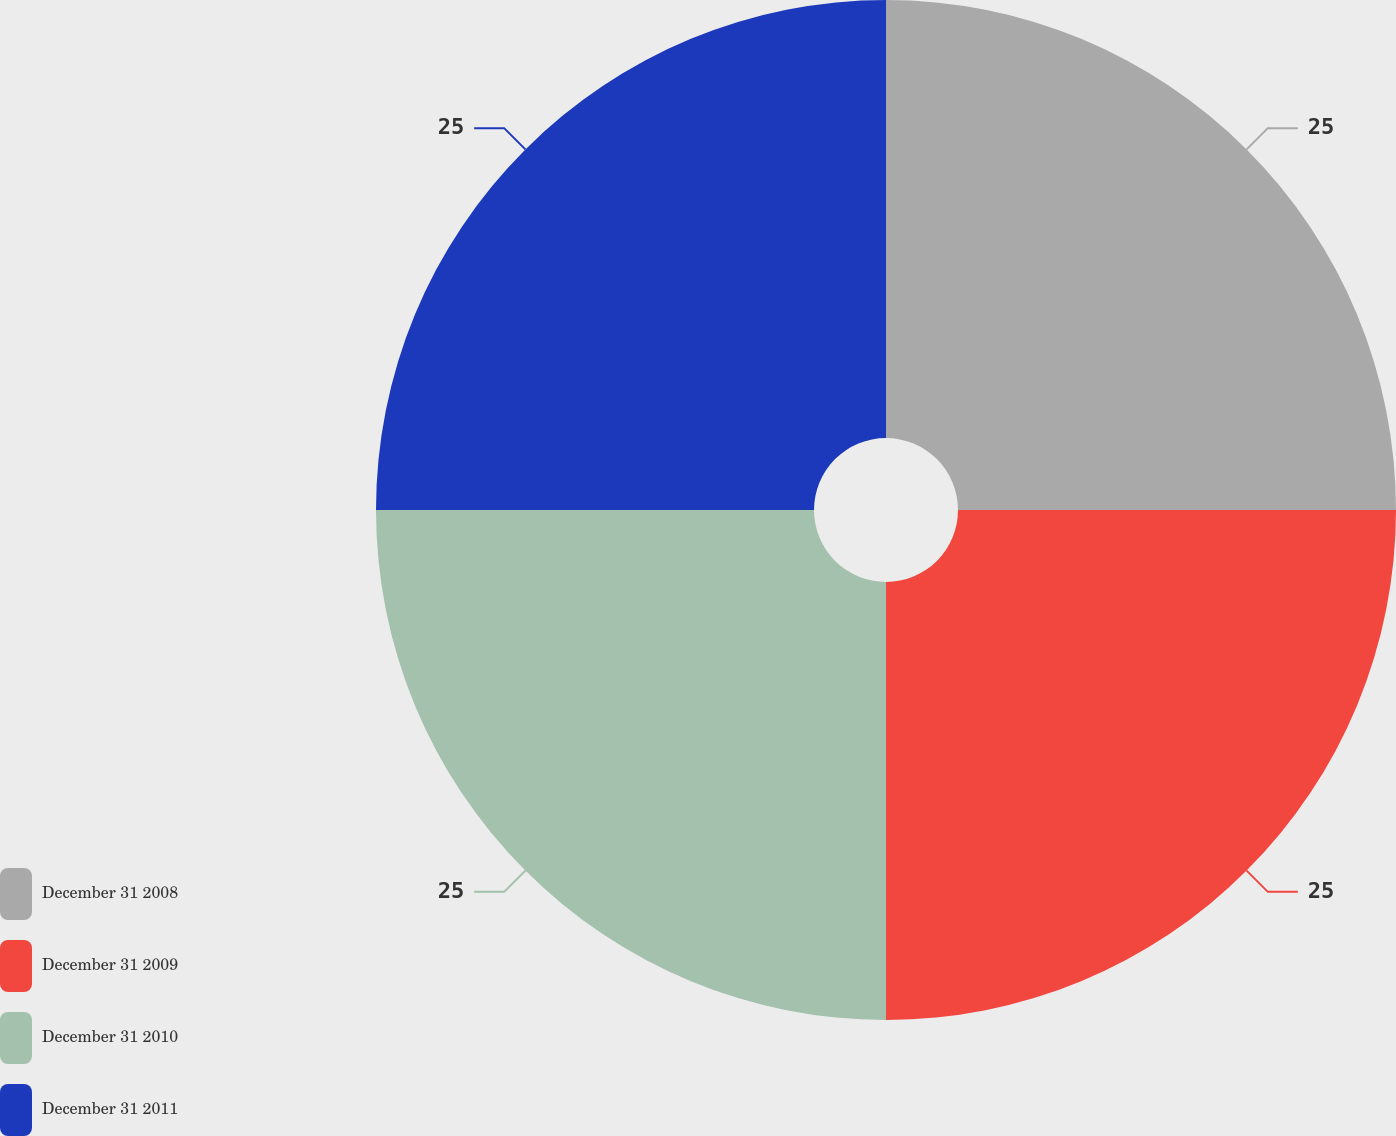Convert chart. <chart><loc_0><loc_0><loc_500><loc_500><pie_chart><fcel>December 31 2008<fcel>December 31 2009<fcel>December 31 2010<fcel>December 31 2011<nl><fcel>25.0%<fcel>25.0%<fcel>25.0%<fcel>25.0%<nl></chart> 